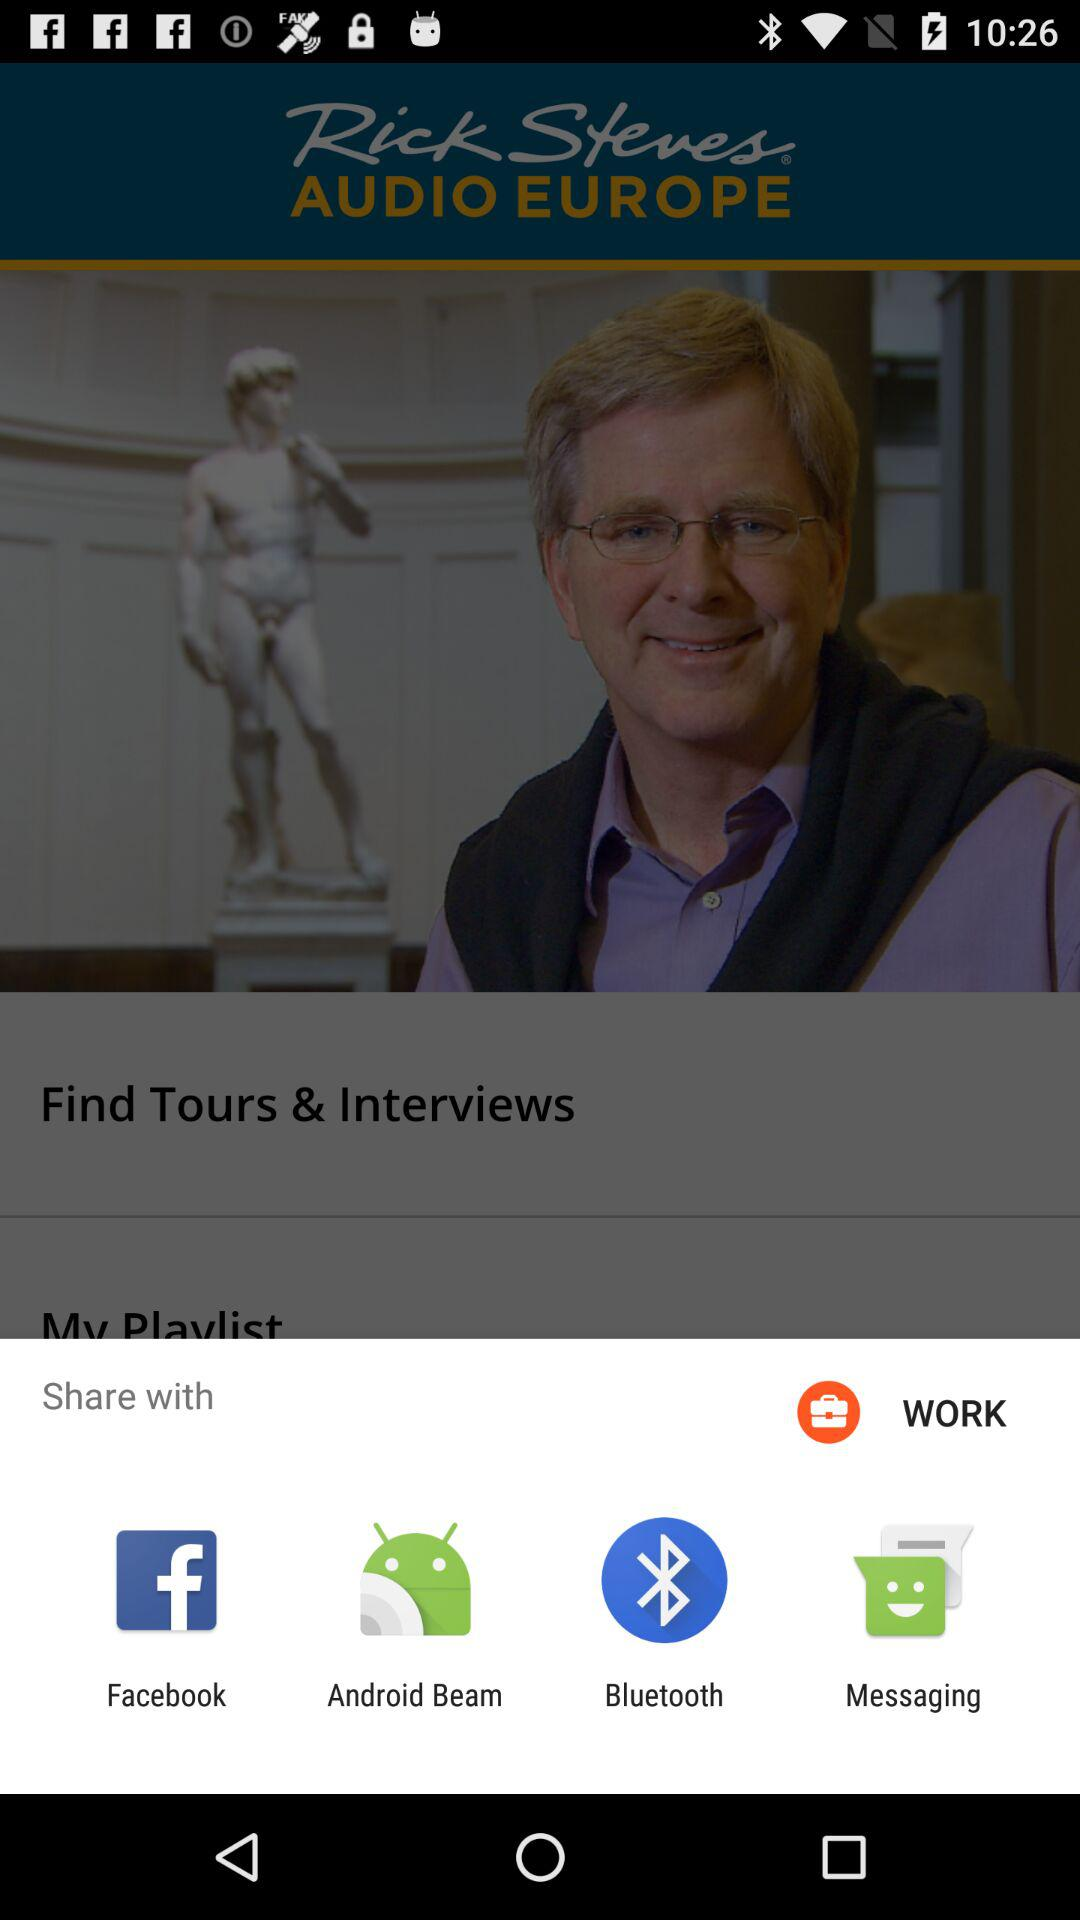Which app can we use to share? The apps are "Facebook", "Android Beam", "Bluetooth" and "Messaging". 